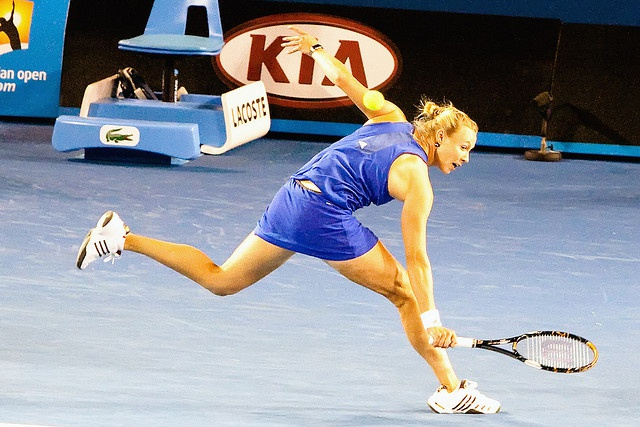Describe the objects in this image and their specific colors. I can see people in orange, ivory, darkgray, and khaki tones, tennis racket in orange, lightgray, black, lightblue, and darkgray tones, chair in orange, darkgray, lightblue, and black tones, and sports ball in orange, khaki, yellow, and lightyellow tones in this image. 